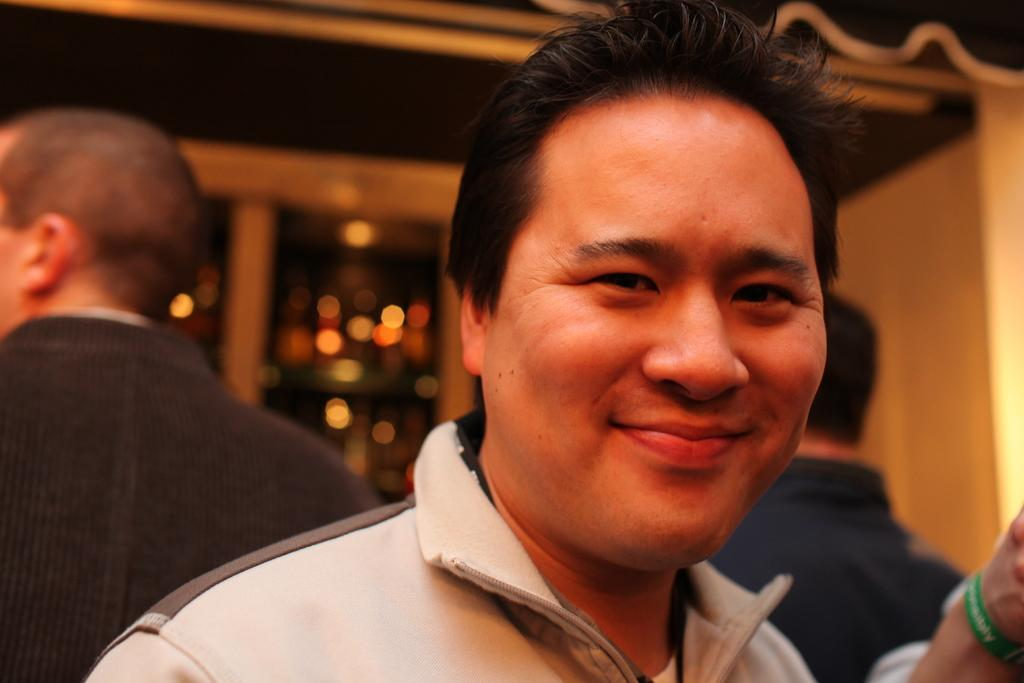Who is the main subject in the image? There is a man in the image. What is the man doing in the image? The man is smiling. Are there any other people visible in the image? Yes, there are other people behind the man. Can you describe the background of the image? The background of the image is blurry. What type of insurance policy does the man have in the image? There is no information about insurance policies in the image; it only shows a man smiling with other people behind him. 